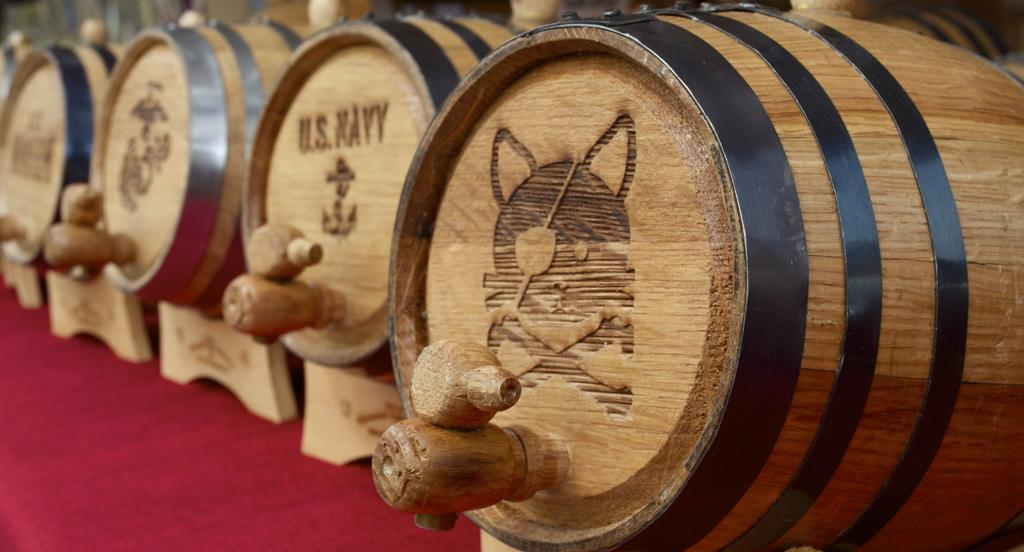What type of containers are present in the image? There are liquid drums in the image. Can you describe the contents of these containers? The liquid drums contain liquid, as indicated by the name. Are there any other objects or features visible in the image? The provided facts do not mention any other objects or features. What type of operation is being conducted in the image? There is no operation or activity being conducted in the image; it only shows liquid drums. What type of base is supporting the liquid drums in the image? The provided facts do not mention any base or support for the liquid drums. 